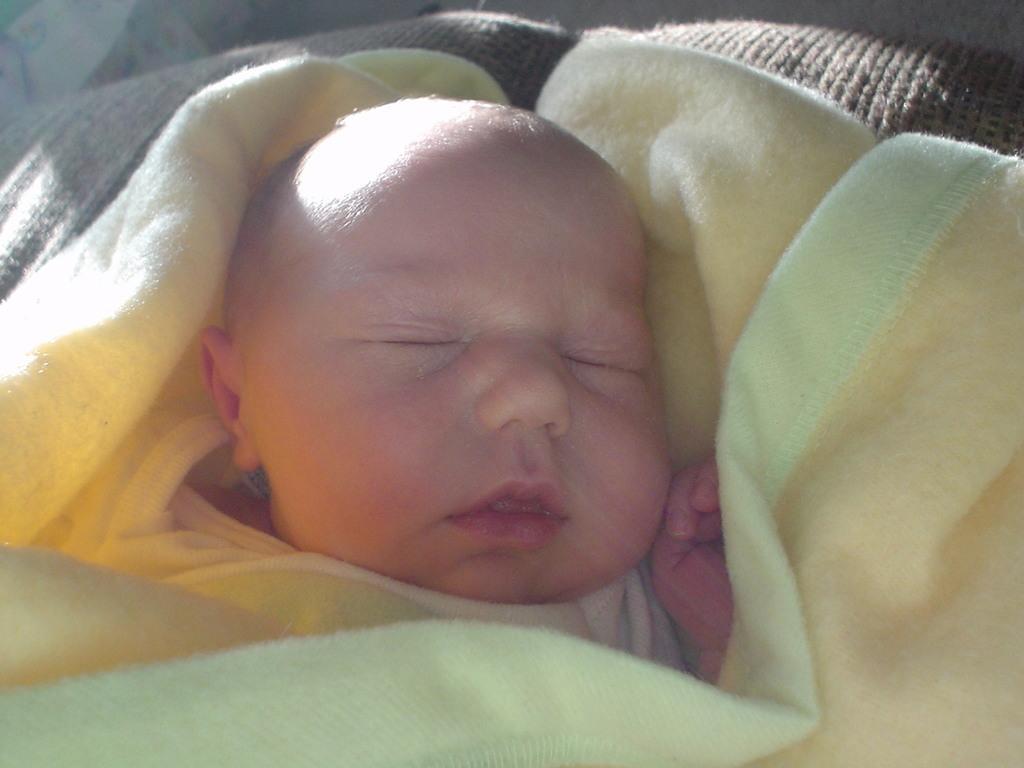Can you describe this image briefly? In this image I can see a baby is lying on a bed and I can see a blanket. This image is taken, may be in a room. 